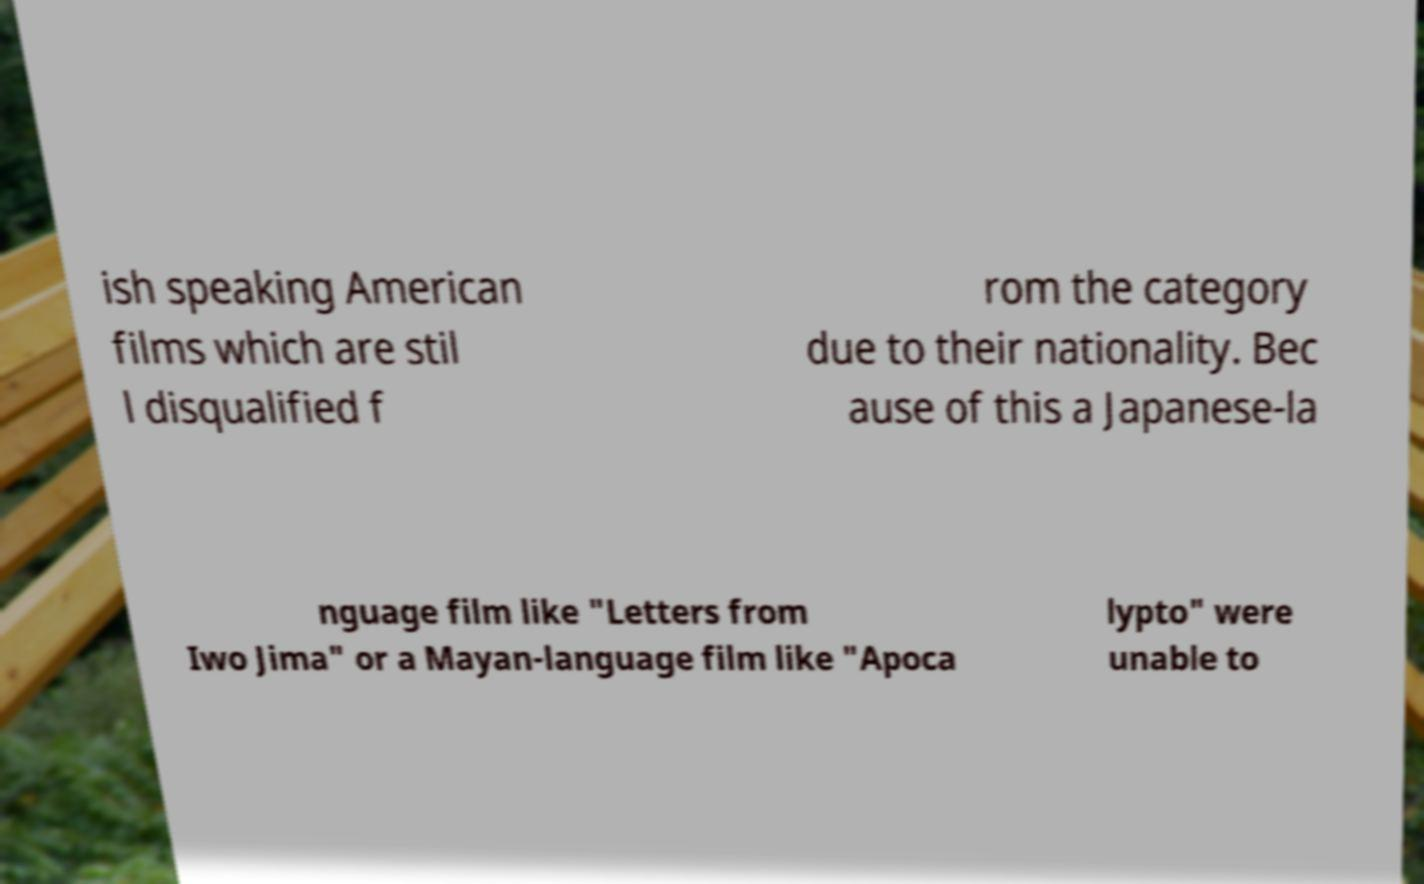Can you accurately transcribe the text from the provided image for me? ish speaking American films which are stil l disqualified f rom the category due to their nationality. Bec ause of this a Japanese-la nguage film like "Letters from Iwo Jima" or a Mayan-language film like "Apoca lypto" were unable to 